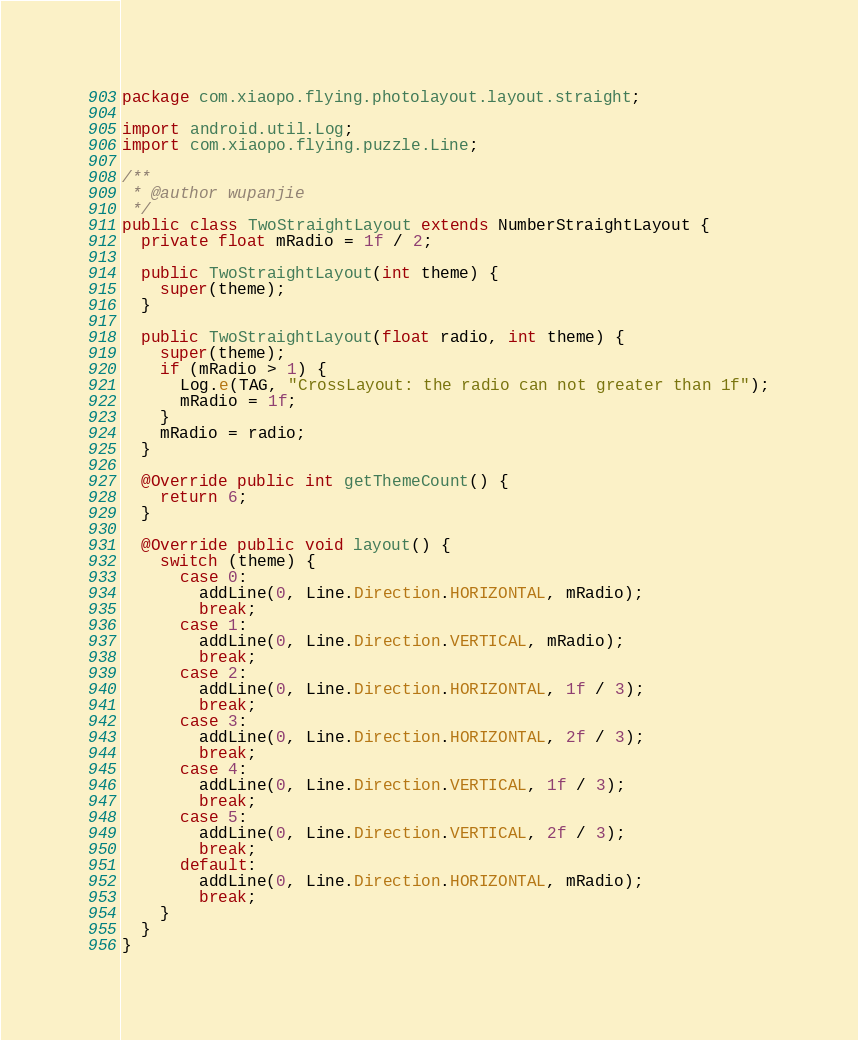Convert code to text. <code><loc_0><loc_0><loc_500><loc_500><_Java_>package com.xiaopo.flying.photolayout.layout.straight;

import android.util.Log;
import com.xiaopo.flying.puzzle.Line;

/**
 * @author wupanjie
 */
public class TwoStraightLayout extends NumberStraightLayout {
  private float mRadio = 1f / 2;

  public TwoStraightLayout(int theme) {
    super(theme);
  }

  public TwoStraightLayout(float radio, int theme) {
    super(theme);
    if (mRadio > 1) {
      Log.e(TAG, "CrossLayout: the radio can not greater than 1f");
      mRadio = 1f;
    }
    mRadio = radio;
  }

  @Override public int getThemeCount() {
    return 6;
  }

  @Override public void layout() {
    switch (theme) {
      case 0:
        addLine(0, Line.Direction.HORIZONTAL, mRadio);
        break;
      case 1:
        addLine(0, Line.Direction.VERTICAL, mRadio);
        break;
      case 2:
        addLine(0, Line.Direction.HORIZONTAL, 1f / 3);
        break;
      case 3:
        addLine(0, Line.Direction.HORIZONTAL, 2f / 3);
        break;
      case 4:
        addLine(0, Line.Direction.VERTICAL, 1f / 3);
        break;
      case 5:
        addLine(0, Line.Direction.VERTICAL, 2f / 3);
        break;
      default:
        addLine(0, Line.Direction.HORIZONTAL, mRadio);
        break;
    }
  }
}
</code> 